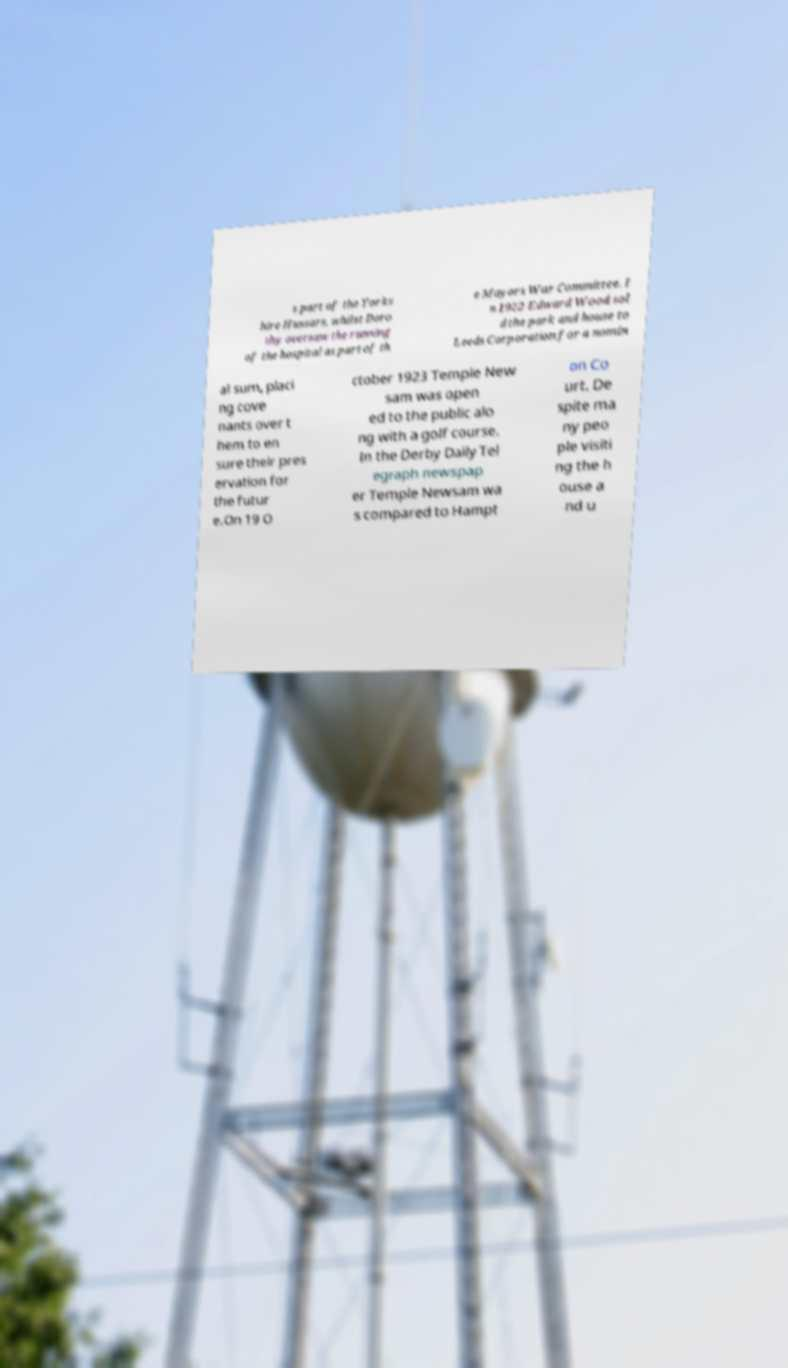Could you extract and type out the text from this image? s part of the Yorks hire Hussars, whilst Doro thy oversaw the running of the hospital as part of th e Mayors War Committee. I n 1922 Edward Wood sol d the park and house to Leeds Corporation for a nomin al sum, placi ng cove nants over t hem to en sure their pres ervation for the futur e.On 19 O ctober 1923 Temple New sam was open ed to the public alo ng with a golf course. In the Derby Daily Tel egraph newspap er Temple Newsam wa s compared to Hampt on Co urt. De spite ma ny peo ple visiti ng the h ouse a nd u 